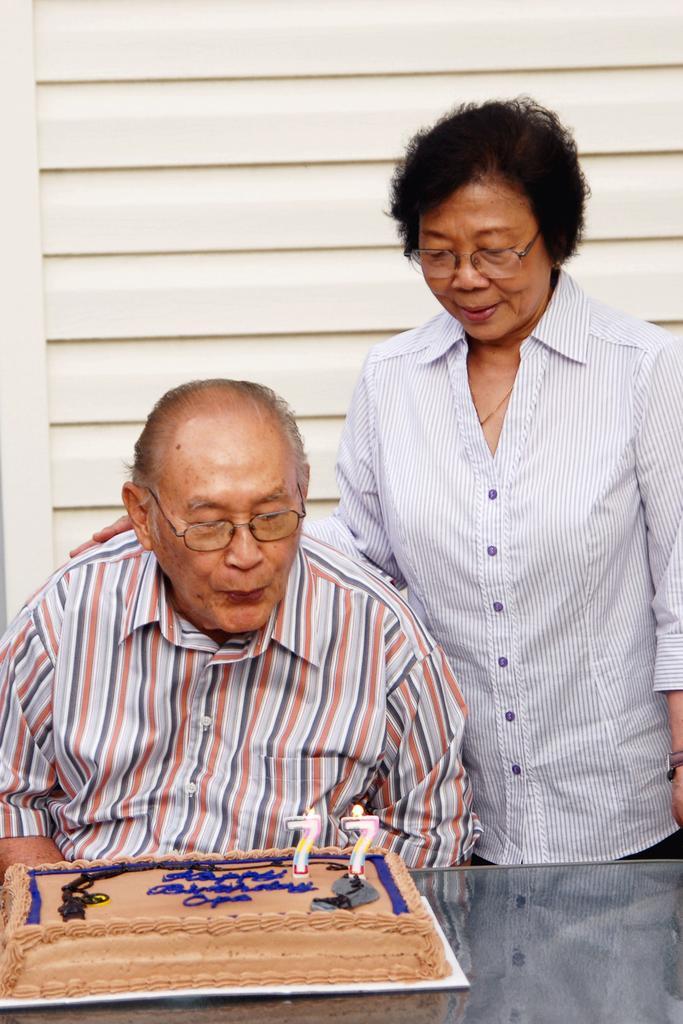In one or two sentences, can you explain what this image depicts? The person sitting in chair is blowing candles which is on the cake in front of him and there is another person standing beside him. 